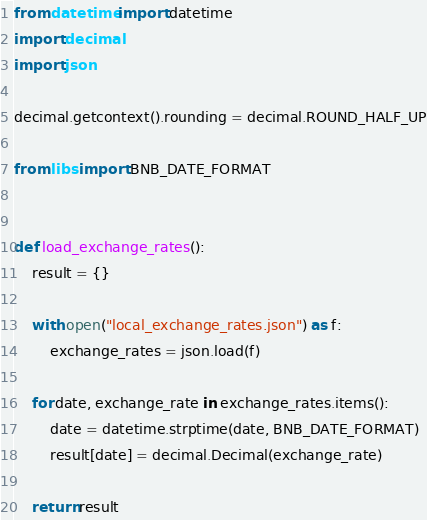<code> <loc_0><loc_0><loc_500><loc_500><_Python_>from datetime import datetime
import decimal
import json

decimal.getcontext().rounding = decimal.ROUND_HALF_UP

from libs import BNB_DATE_FORMAT


def load_exchange_rates():
    result = {}

    with open("local_exchange_rates.json") as f:
        exchange_rates = json.load(f)

    for date, exchange_rate in exchange_rates.items():
        date = datetime.strptime(date, BNB_DATE_FORMAT)
        result[date] = decimal.Decimal(exchange_rate)

    return result
</code> 